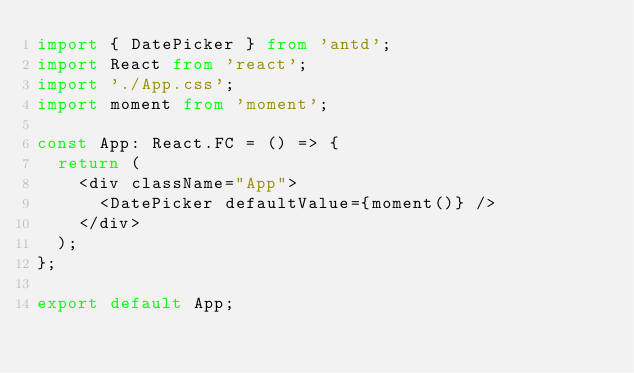<code> <loc_0><loc_0><loc_500><loc_500><_TypeScript_>import { DatePicker } from 'antd';
import React from 'react';
import './App.css';
import moment from 'moment';

const App: React.FC = () => {
  return (
    <div className="App">
      <DatePicker defaultValue={moment()} />
    </div>
  );
};

export default App;
</code> 